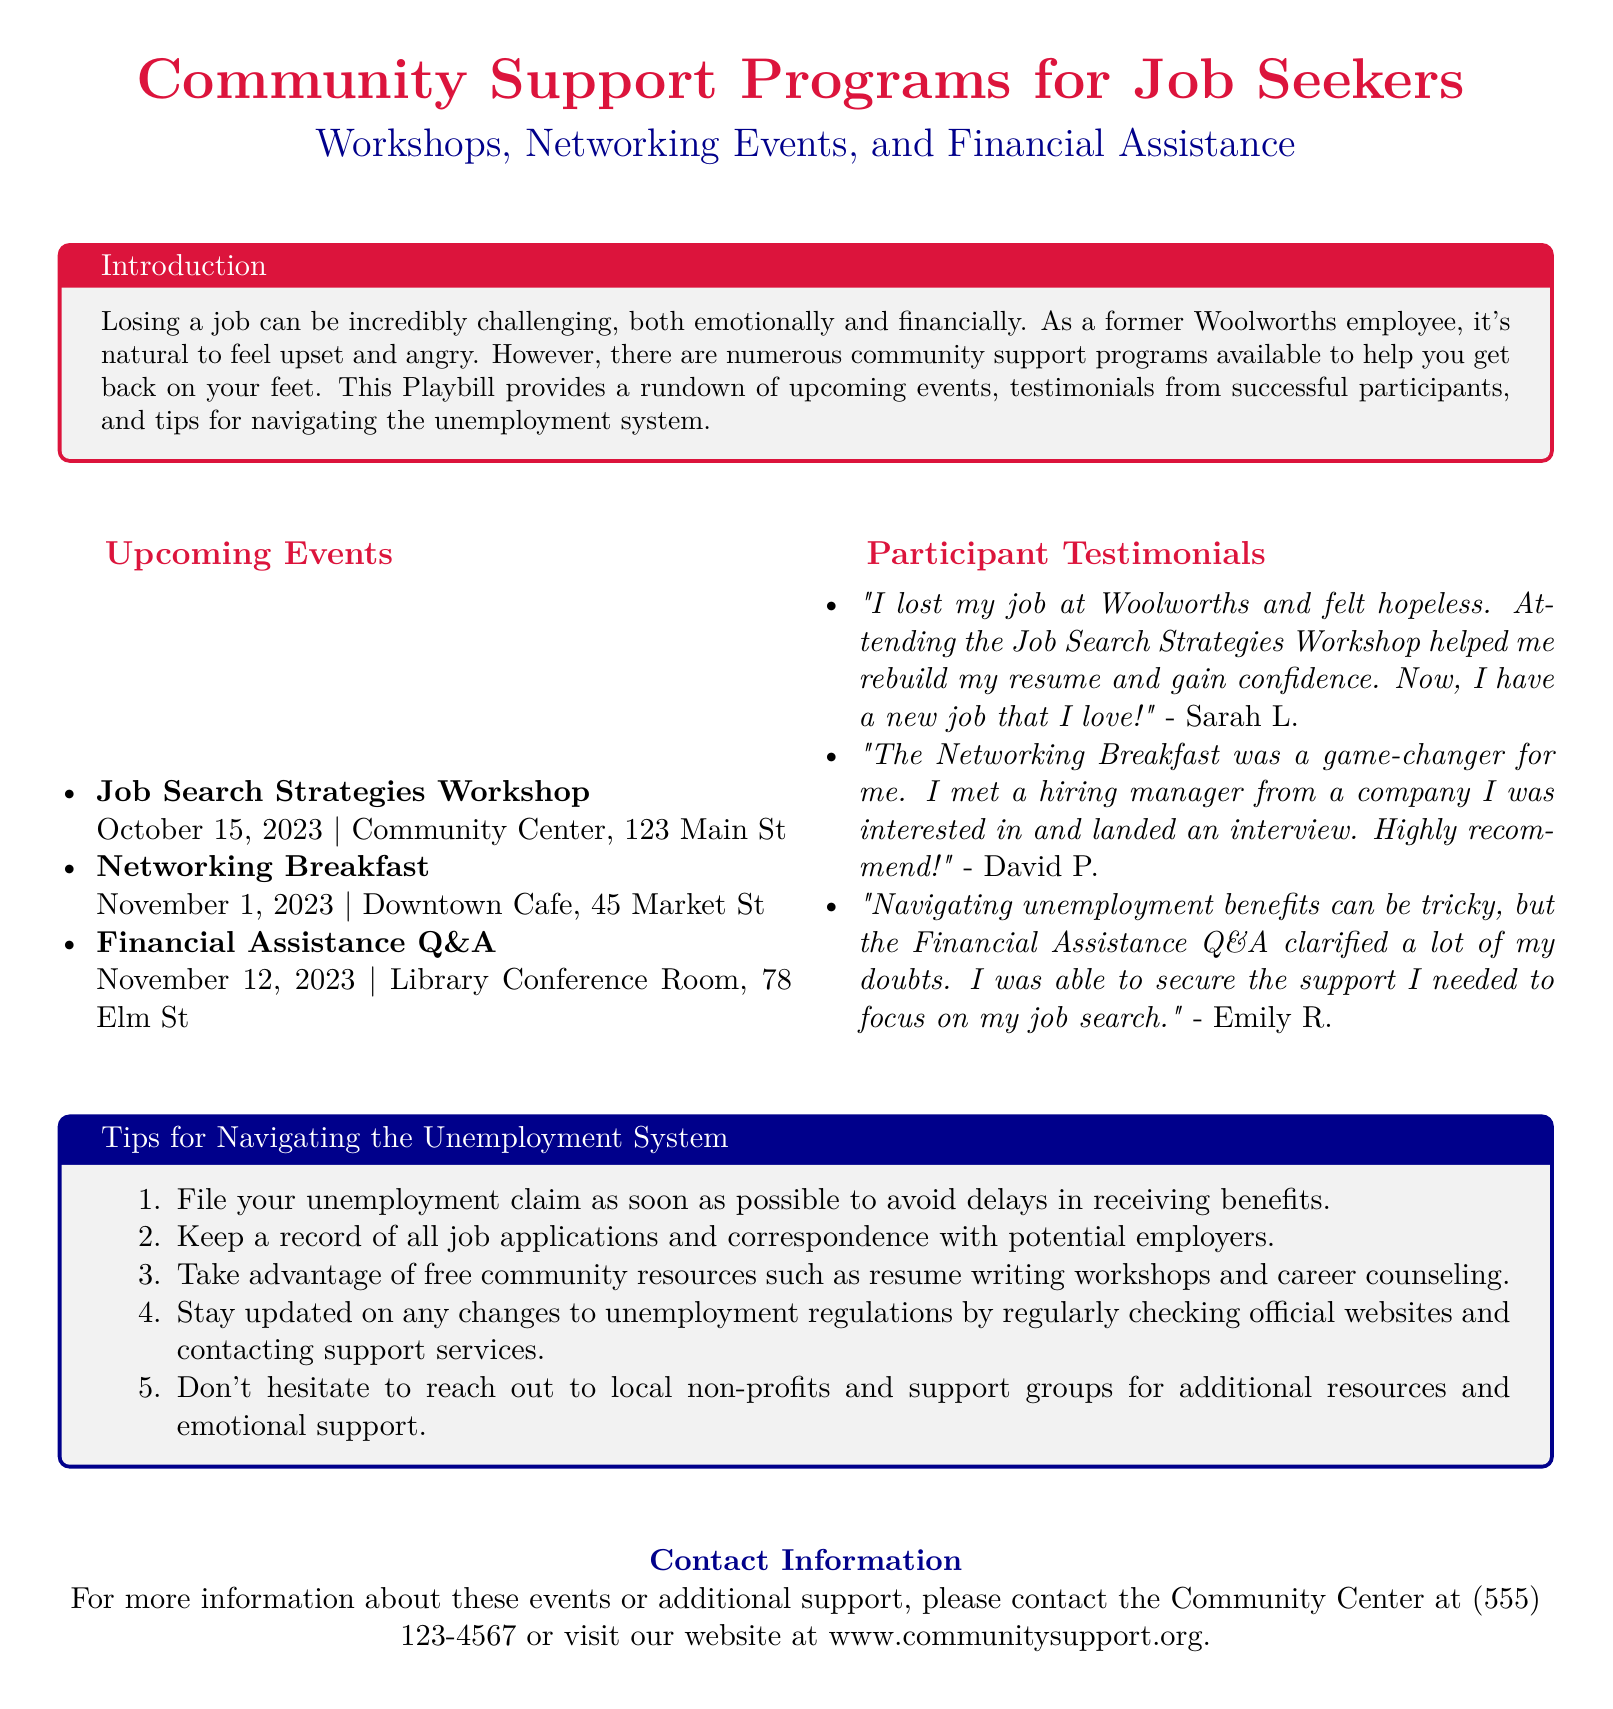What is the date of the Job Search Strategies Workshop? The date is listed under Upcoming Events section of the document.
Answer: October 15, 2023 Where is the Networking Breakfast held? This information is provided in the Upcoming Events section.
Answer: Downtown Cafe, 45 Market St Who gave a testimonial about the Job Search Strategies Workshop? The testimonials section contains personal experiences of participants.
Answer: Sarah L What type of assistance is discussed in the Financial Assistance Q&A? The title specifies the focus of this event in the Upcoming Events section.
Answer: Financial Assistance What is one tip for navigating the unemployment system? This information is found in the Tips for Navigating the Unemployment System box in the document.
Answer: File your unemployment claim as soon as possible What is the main purpose of the Community Support Programs? The introduction explains the aim of these programs in the context of job loss.
Answer: Help you get back on your feet How can participants find more information about events? The contact information section provides guidance on where to look for additional details.
Answer: Community Center, (555) 123-4567 What emotion does the introduction acknowledge regarding job loss? The introduction describes how losing a job can affect individuals emotionally.
Answer: Angry When is the Financial Assistance Q&A scheduled? This information can be found in the Upcoming Events section.
Answer: November 12, 2023 